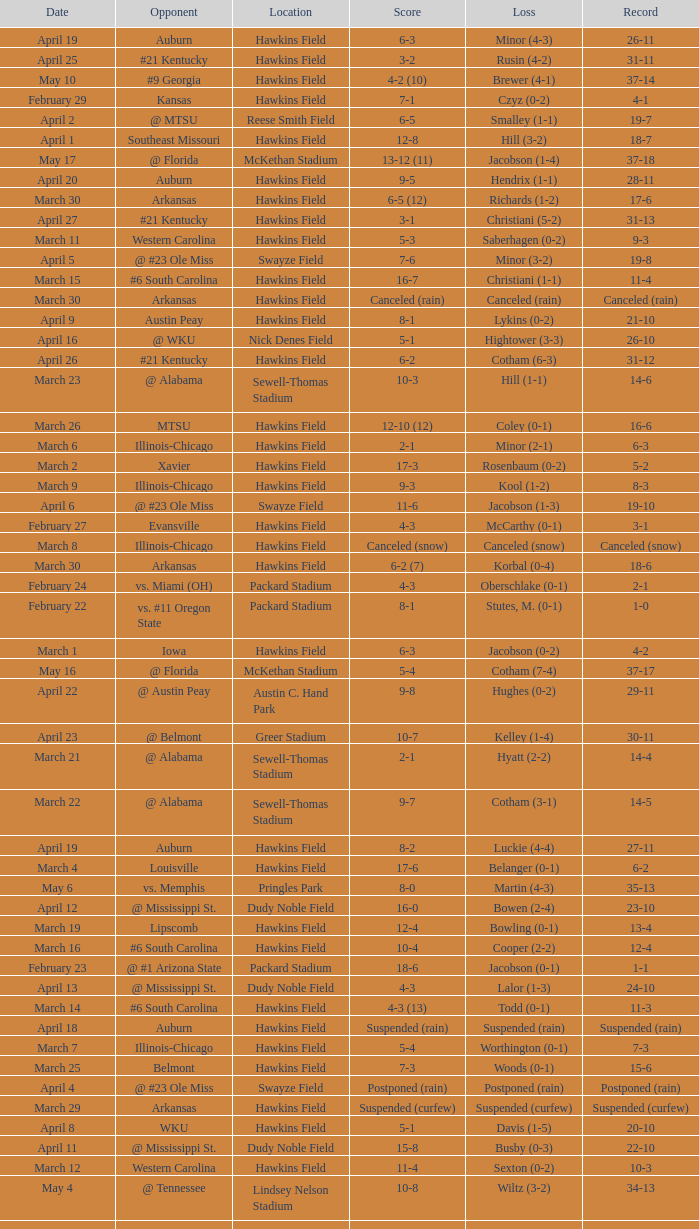What was the location of the game when the record was 2-1? Packard Stadium. 